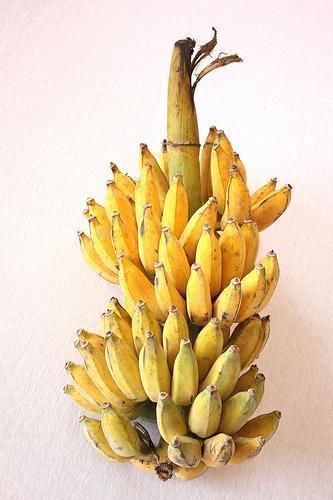How many bunches of bananas are there?
Give a very brief answer. 1. How many rows of bananas are there?
Give a very brief answer. 6. 